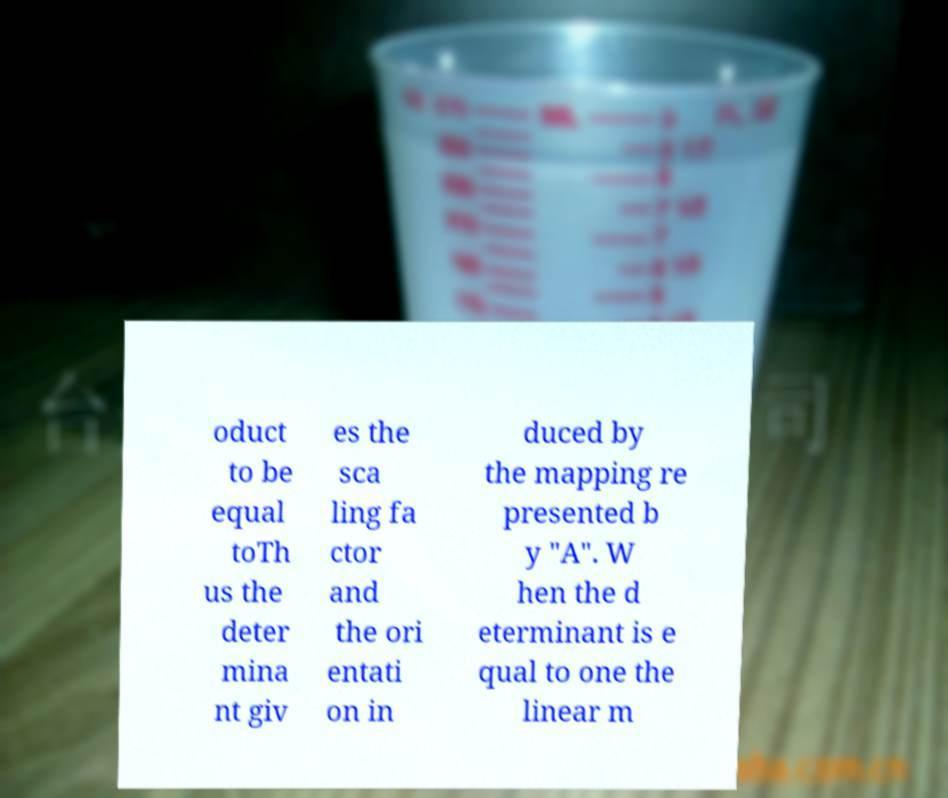Please read and relay the text visible in this image. What does it say? oduct to be equal toTh us the deter mina nt giv es the sca ling fa ctor and the ori entati on in duced by the mapping re presented b y "A". W hen the d eterminant is e qual to one the linear m 